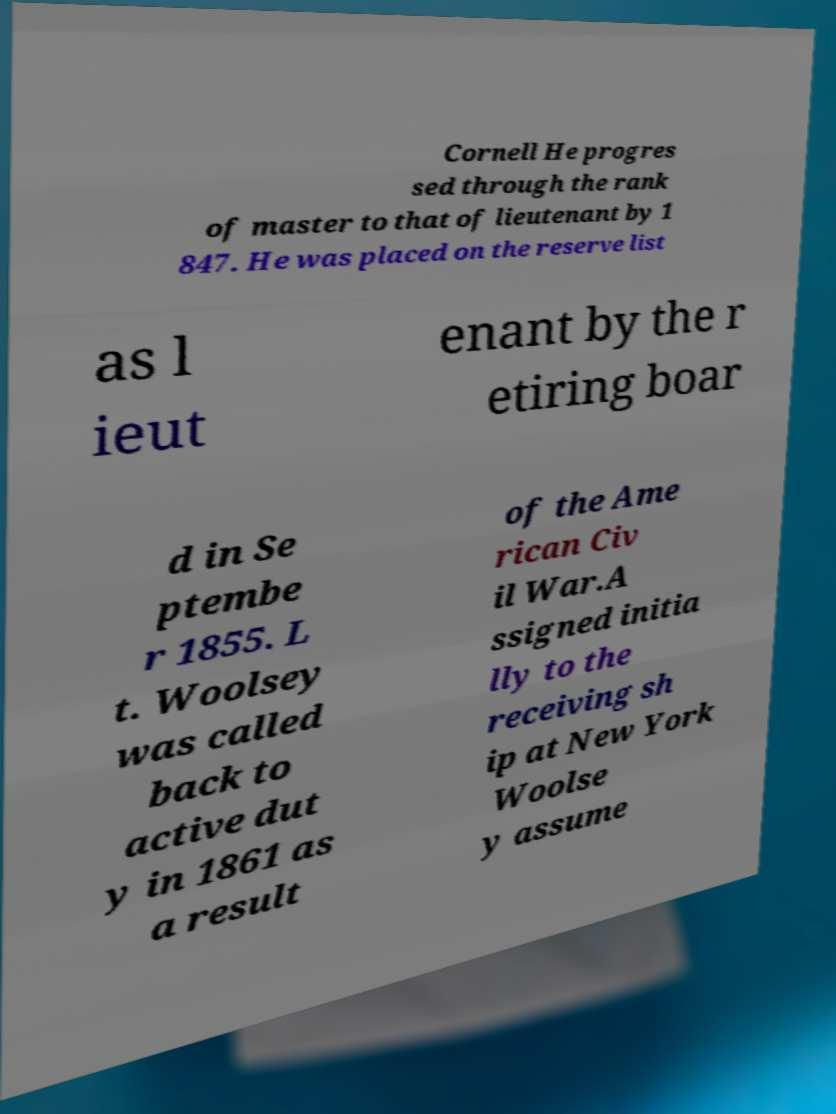There's text embedded in this image that I need extracted. Can you transcribe it verbatim? Cornell He progres sed through the rank of master to that of lieutenant by 1 847. He was placed on the reserve list as l ieut enant by the r etiring boar d in Se ptembe r 1855. L t. Woolsey was called back to active dut y in 1861 as a result of the Ame rican Civ il War.A ssigned initia lly to the receiving sh ip at New York Woolse y assume 